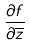Convert formula to latex. <formula><loc_0><loc_0><loc_500><loc_500>\frac { \partial f } { \partial \overline { z } }</formula> 